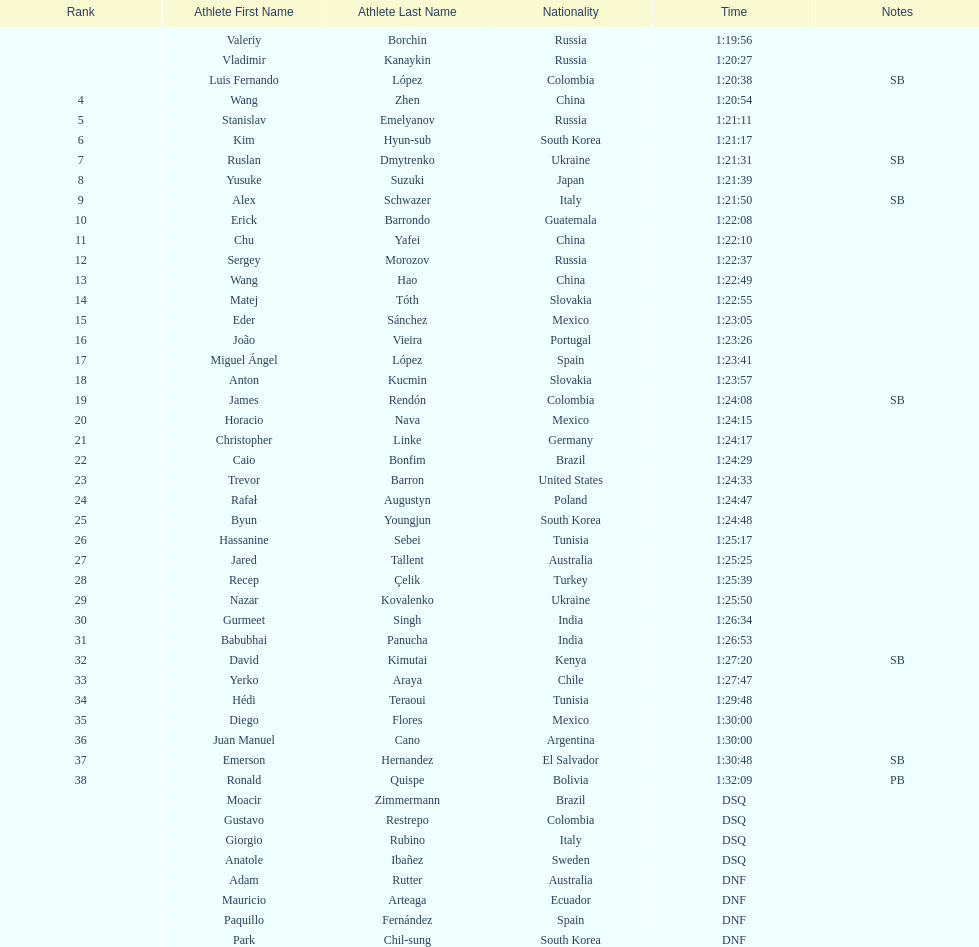Name all athletes were slower than horacio nava. Christopher Linke, Caio Bonfim, Trevor Barron, Rafał Augustyn, Byun Youngjun, Hassanine Sebei, Jared Tallent, Recep Çelik, Nazar Kovalenko, Gurmeet Singh, Babubhai Panucha, David Kimutai, Yerko Araya, Hédi Teraoui, Diego Flores, Juan Manuel Cano, Emerson Hernandez, Ronald Quispe. 